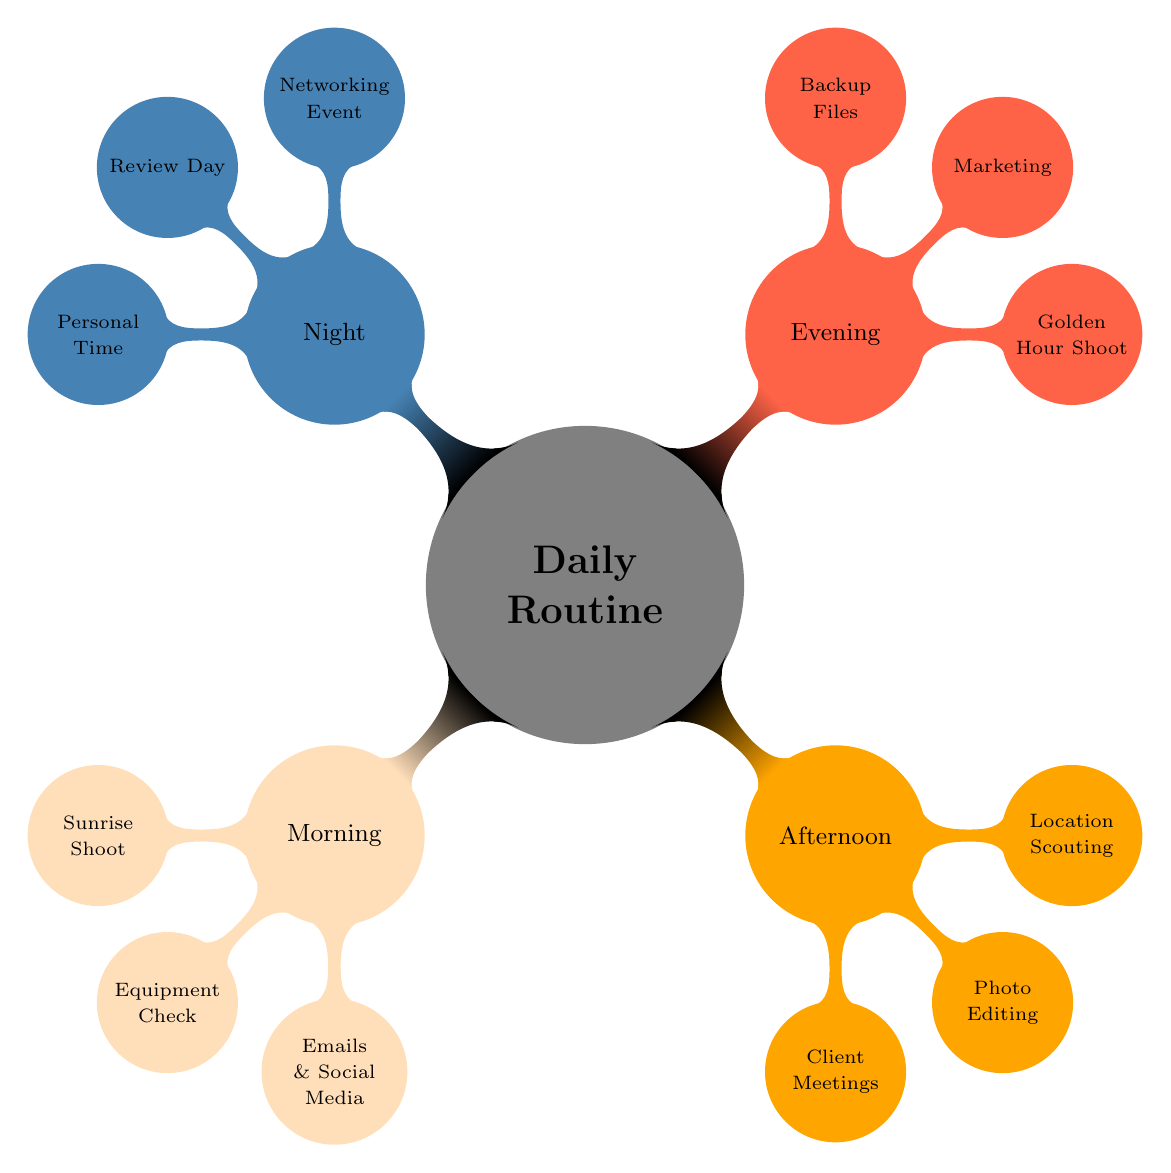What activities are scheduled in the Morning? The diagram indicates that there are three activities scheduled for the Morning: Sunrise Shoot, Equipment Check, and Emails and Social Media.
Answer: Sunrise Shoot, Equipment Check, Emails and Social Media How many nodes are there in the Evening section? In the Evening section, there are three nodes: Golden Hour Shoot, Marketing, and Backup Files. Therefore, the total count of nodes in this segment is three.
Answer: 3 What is a task performed during the Night? According to the diagram, one of the tasks performed during the Night is attending a Networking Event.
Answer: Networking Event Which two sections contain tasks related to photography? The sections labeled Morning and Evening both contain tasks directly related to photography: Morning includes Sunrise Shoot, while Evening includes Golden Hour Shoot.
Answer: Morning, Evening What is the relationship between Photo Editing and Client Meetings? Photo Editing and Client Meetings are both tasks located in the Afternoon section. This indicates a direct relationship as they occur during the same time period, helping the photographer manage workflow effectively.
Answer: Both are in Afternoon What is the purpose of the task "Review Day"? The task "Review Day" is positioned in the Night section and its purpose is to reflect on the day's progress and plan for tomorrow. This serves to enhance productivity and prepare for the next day.
Answer: Reflect on the day's progress How many total sections are in the Daily Routine? The Daily Routine is divided into four sections: Morning, Afternoon, Evening, and Night. Therefore, the total number of sections is four.
Answer: 4 What are the tasks involved in the Afternoon section? The Afternoon section comprises three tasks: Client Meetings, Photo Editing, and Location Scouting. Listing out these tasks reflects the activities planned during that time.
Answer: Client Meetings, Photo Editing, Location Scouting Which task aims at social media engagement? The task aimed at social media engagement is found in the Morning section, labeled Emails and Social Media. Engaging in this task helps maintain online presence.
Answer: Emails and Social Media 